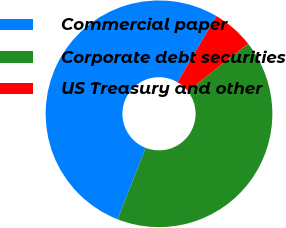Convert chart. <chart><loc_0><loc_0><loc_500><loc_500><pie_chart><fcel>Commercial paper<fcel>Corporate debt securities<fcel>US Treasury and other<nl><fcel>52.51%<fcel>41.55%<fcel>5.94%<nl></chart> 